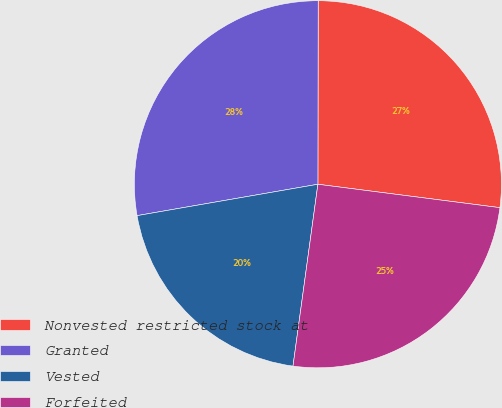Convert chart. <chart><loc_0><loc_0><loc_500><loc_500><pie_chart><fcel>Nonvested restricted stock at<fcel>Granted<fcel>Vested<fcel>Forfeited<nl><fcel>27.01%<fcel>27.76%<fcel>20.1%<fcel>25.13%<nl></chart> 